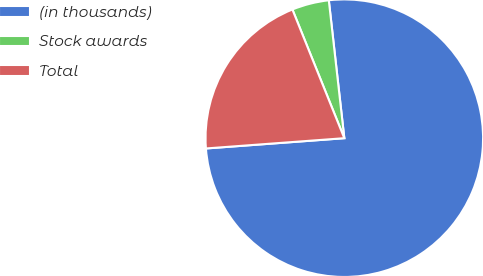Convert chart to OTSL. <chart><loc_0><loc_0><loc_500><loc_500><pie_chart><fcel>(in thousands)<fcel>Stock awards<fcel>Total<nl><fcel>75.61%<fcel>4.32%<fcel>20.08%<nl></chart> 